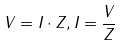Convert formula to latex. <formula><loc_0><loc_0><loc_500><loc_500>V = I \cdot Z , I = \frac { V } { Z }</formula> 